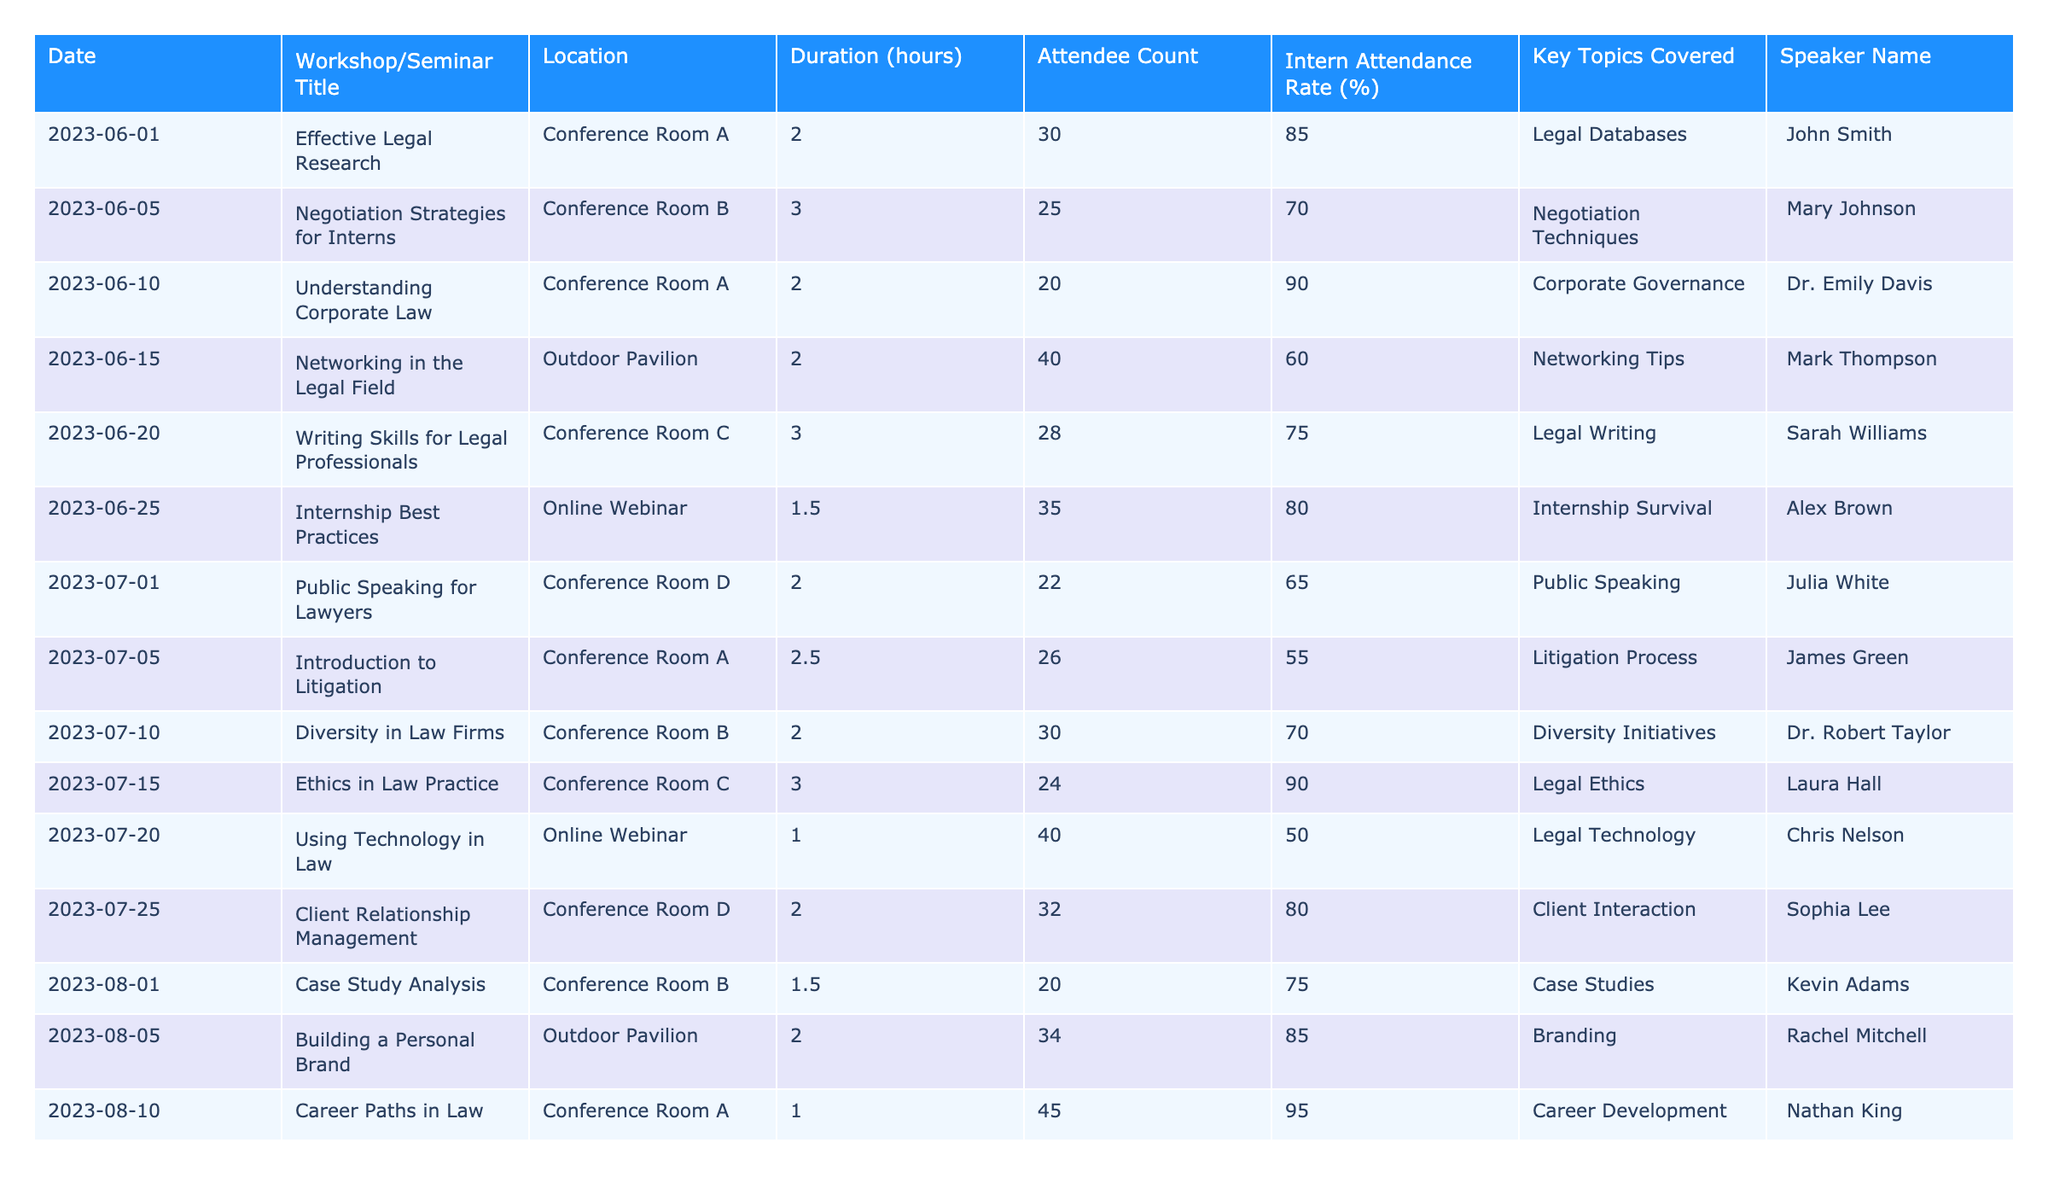What is the title of the workshop held on June 10, 2023? According to the table, on June 10, 2023, the workshop title listed is "Understanding Corporate Law."
Answer: Understanding Corporate Law What is the duration of the "Networking in the Legal Field" workshop? The table states that the "Networking in the Legal Field" workshop has a duration of 2 hours.
Answer: 2 hours Which speaker presented on "Ethics in Law Practice"? The table indicates that Laura Hall was the speaker for "Ethics in Law Practice."
Answer: Laura Hall How many attendees were present at the "Public Speaking for Lawyers" seminar? From the table, we can see that 22 attendees were present at the "Public Speaking for Lawyers" seminar.
Answer: 22 What is the average intern attendance rate across all workshops? To find the average, we can add all the intern attendance rates: (85 + 70 + 90 + 60 + 75 + 80 + 65 + 55 + 70 + 90 + 50 + 80 + 75 + 85 + 95) = 1,210. There are 15 workshops, so the average intern attendance rate is 1,210 / 15 = 80.67%.
Answer: 80.67% Is the internship seminar on July 20, 2023, longer than 1 hour? The table lists the duration of the seminar on July 20, 2023, as 1 hour, which is equal to 1 hour, hence the answer is no.
Answer: No How many workshops had an intern attendance rate of 90% or above? By checking the attendance rates in the table, we find that there are 4 workshops (Effective Legal Research, Understanding Corporate Law, Ethics in Law Practice, and Career Paths in Law) with rates of 90% or above.
Answer: 4 What was the key topic covered in the "Writing Skills for Legal Professionals" workshop? According to the table, the key topic covered in the "Writing Skills for Legal Professionals" workshop was "Legal Writing."
Answer: Legal Writing Which workshop had the highest attendee count, and how many attendees were present? Reviewing the table, the workshop with the highest attendee count is "Career Paths in Law," which had 45 attendees.
Answer: Career Paths in Law, 45 attendees What is the difference in intern attendance rates between the "Diversity in Law Firms" and "Networking in the Legal Field" workshops? From the table, the attendance rate for "Diversity in Law Firms" is 70% while for "Networking in the Legal Field" it is 60%. Thus, the difference is 70 - 60 = 10%.
Answer: 10% 